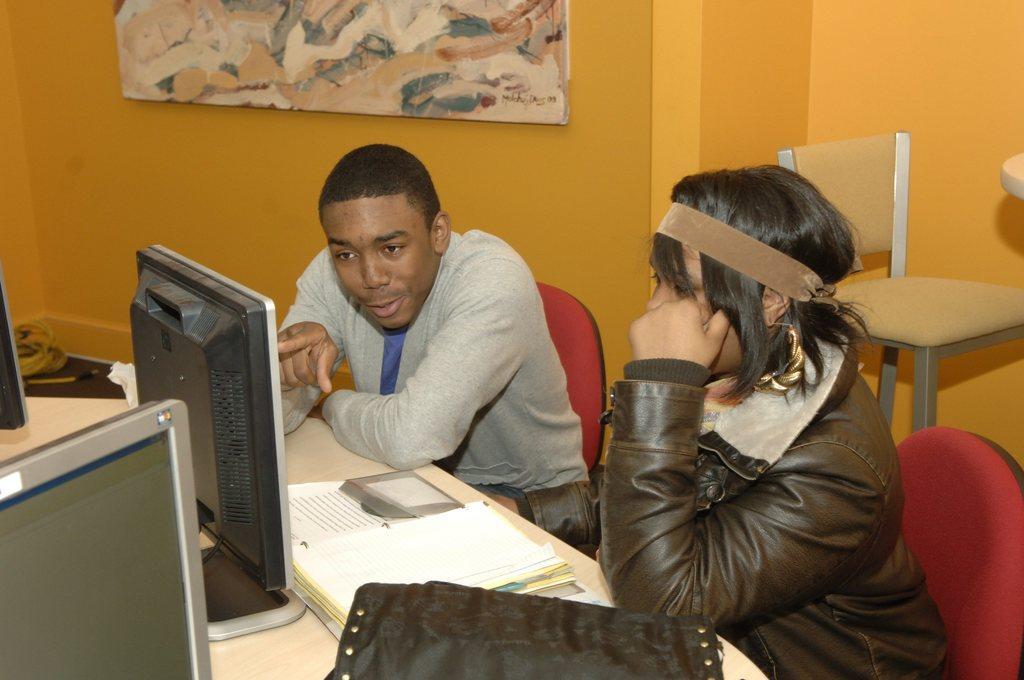In one or two sentences, can you explain what this image depicts? In this picture there are two persons sitting on the chair, there is a table in front of them, there is a monitor, a book, a bag. Both of them are staring at the computer. In the backdrop there is a wall with a photo frame 